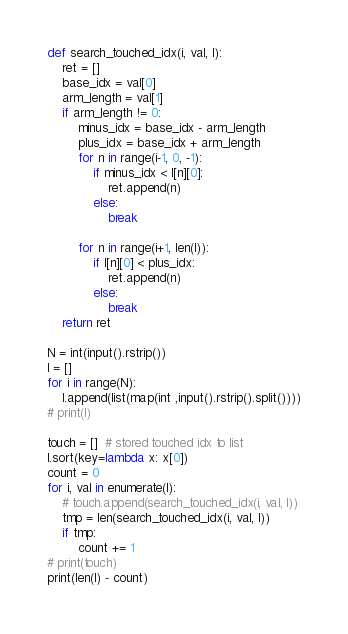Convert code to text. <code><loc_0><loc_0><loc_500><loc_500><_Python_>def search_touched_idx(i, val, l):
    ret = []
    base_idx = val[0]
    arm_length = val[1]
    if arm_length != 0:
        minus_idx = base_idx - arm_length
        plus_idx = base_idx + arm_length
        for n in range(i-1, 0, -1):
            if minus_idx < l[n][0]:
                ret.append(n)
            else:
                break

        for n in range(i+1, len(l)):
            if l[n][0] < plus_idx:
                ret.append(n)
            else:
                break
    return ret

N = int(input().rstrip())
l = []
for i in range(N):
    l.append(list(map(int ,input().rstrip().split())))
# print(l)

touch = []  # stored touched idx to list
l.sort(key=lambda x: x[0])
count = 0
for i, val in enumerate(l):
    # touch.append(search_touched_idx(i, val, l))
    tmp = len(search_touched_idx(i, val, l))
    if tmp:
        count += 1
# print(touch)
print(len(l) - count)
</code> 